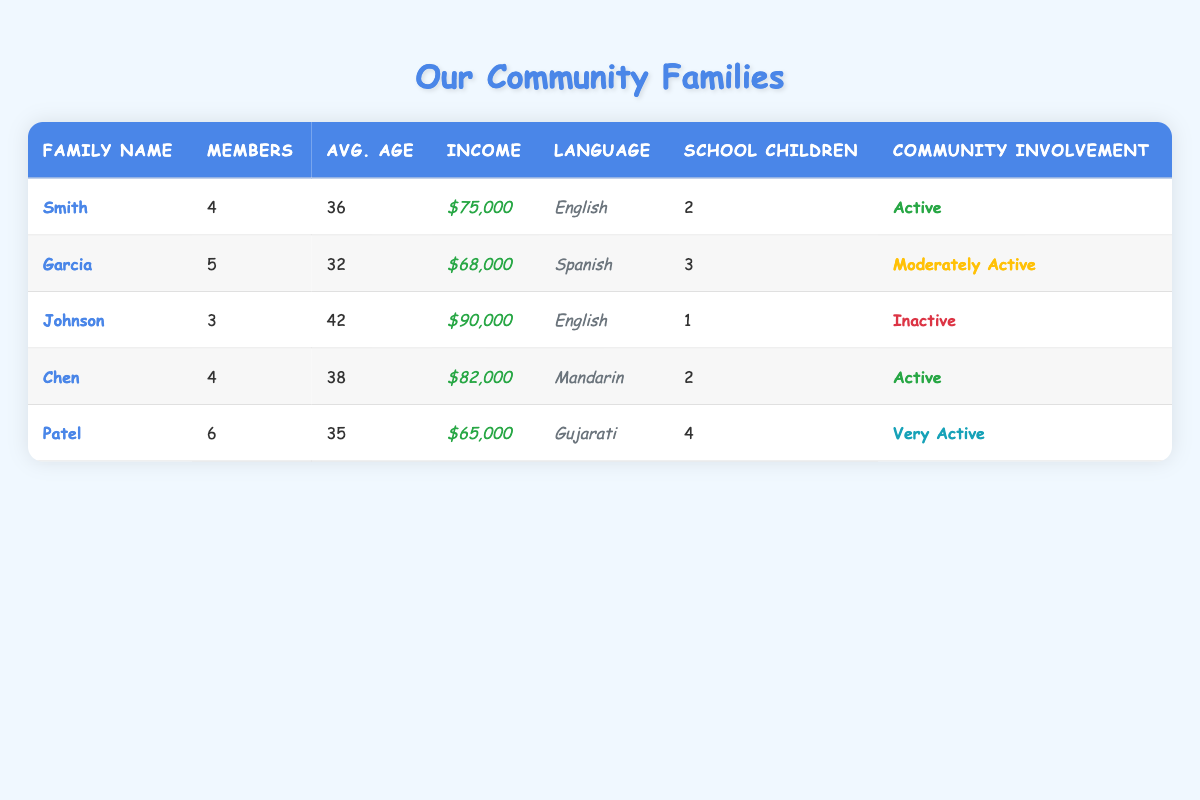What is the household income of the Garcia family? The household income for the Garcia family is listed directly in the table under 'Income.' It shows "$68,000."
Answer: $68,000 How many children are in school for the Patel family? The table indicates that the Patel family has 4 children in school, which is mentioned in the 'School Children' column.
Answer: 4 What is the average age of the Johnson family members? Looking at the 'Avg. Age' column for the Johnson family, it shows 42 as the average age of family members.
Answer: 42 How many total family members are there across all families? To find the total members, we sum the number of members from each family: 4 + 5 + 3 + 4 + 6 = 22.
Answer: 22 How many families have a household income above $70,000? By checking the income values, the Smith ($75,000), Johnson ($90,000), and Chen ($82,000) families have incomes above $70,000. That makes a total of 3 families.
Answer: 3 Is the Chen family involved in the community? The involvement of the Chen family is noted under 'Community Involvement' as "Active," indicating they are indeed involved.
Answer: Yes What is the average household income of the families listed in the table? The total household incomes are $75,000 + $68,000 + $90,000 + $82,000 + $65,000 = $380,000. With 5 families, the average is $380,000 / 5 = $76,000.
Answer: $76,000 Which family has the most members, and how many members do they have? Looking at the 'Members' column, the Patel family has the highest number with 6 members.
Answer: Patel, 6 members How many families have children in school? From the table, families with children in school are the Smith (2), Garcia (3), Johnson (1), Chen (2), and Patel (4) families, which totals 5 families.
Answer: 5 What percentage of the families are active in community involvement? 3 out of the 5 families (Smith, Chen, Patel) are either "Active" or "Very Active," which is (3/5)*100 = 60%.
Answer: 60% 